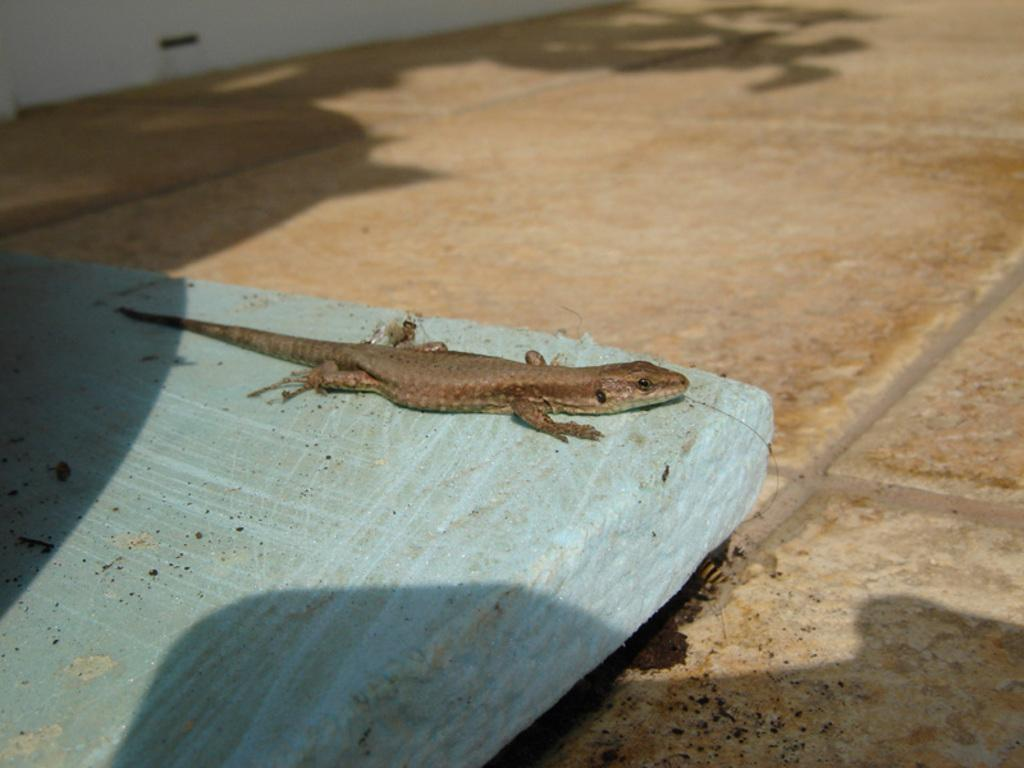What type of animal is in the image? There is a reptile in the image. What is the reptile resting on? The reptile is on an object. Where is the object located? The object is on the floor. What can be seen in the background of the image? There is a wall visible in the image. What type of liquid is being poured from the pan in the image? There is no pan or liquid present in the image; it features a reptile on an object with a wall in the background. 